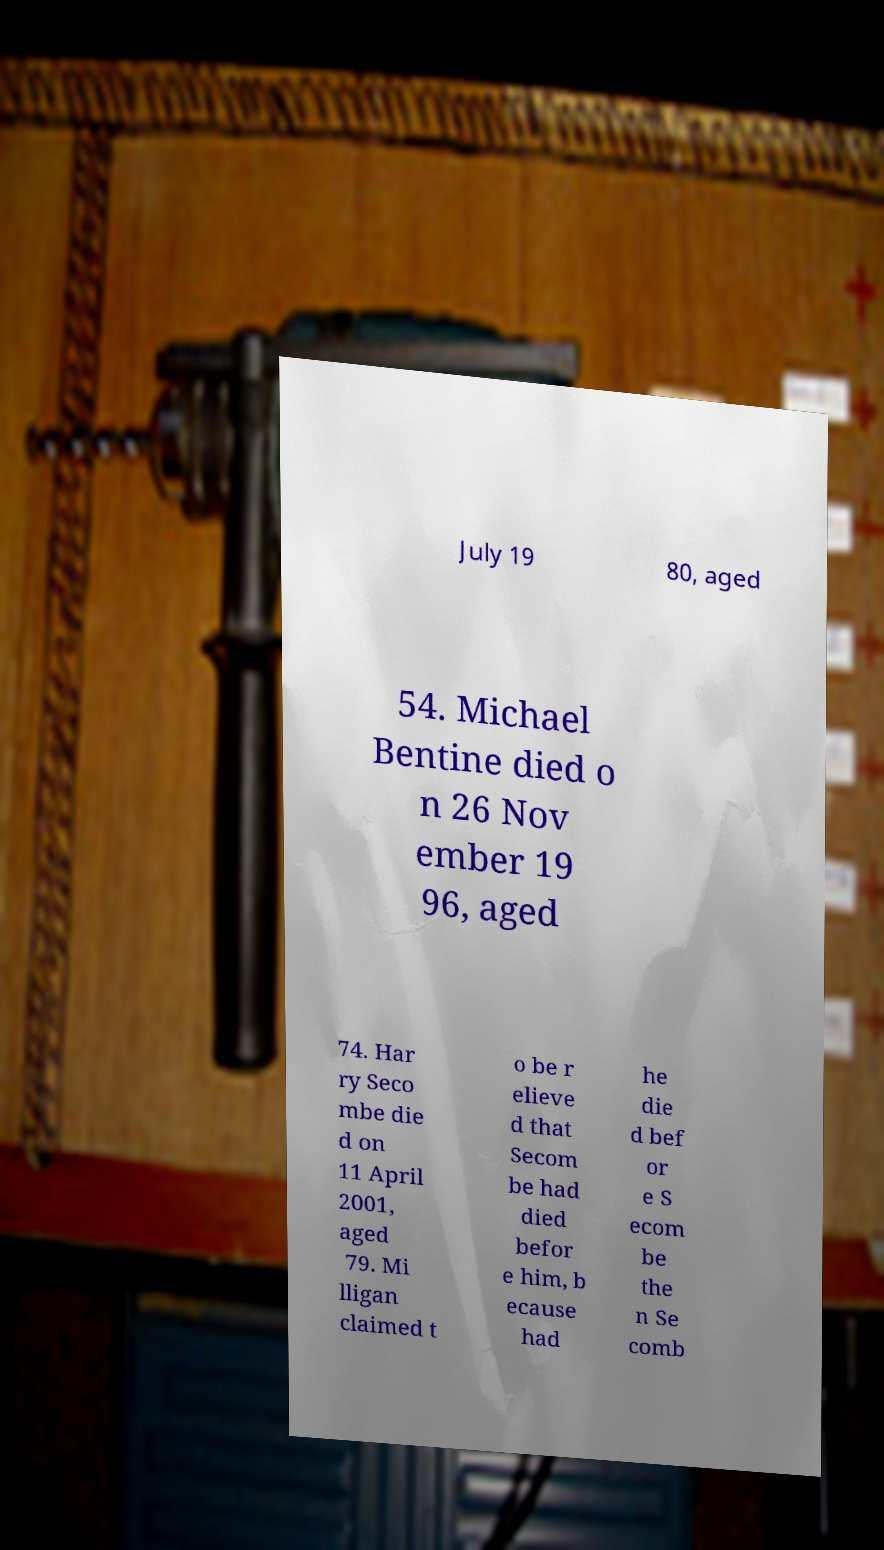Please read and relay the text visible in this image. What does it say? July 19 80, aged 54. Michael Bentine died o n 26 Nov ember 19 96, aged 74. Har ry Seco mbe die d on 11 April 2001, aged 79. Mi lligan claimed t o be r elieve d that Secom be had died befor e him, b ecause had he die d bef or e S ecom be the n Se comb 